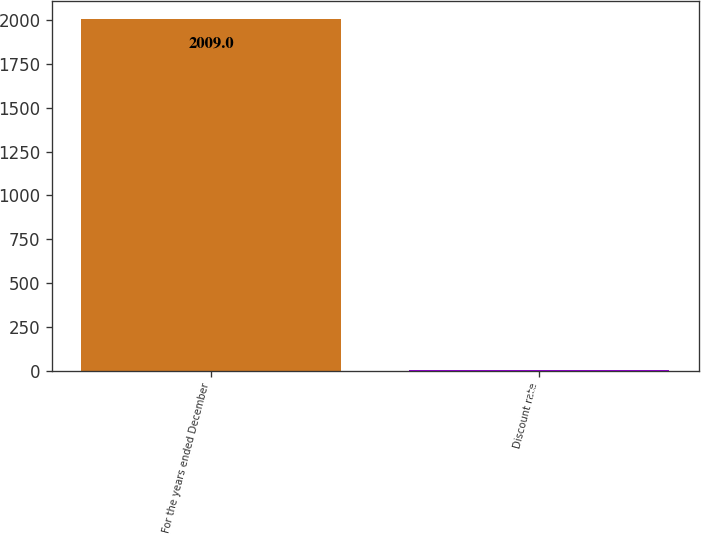<chart> <loc_0><loc_0><loc_500><loc_500><bar_chart><fcel>For the years ended December<fcel>Discount rate<nl><fcel>2009<fcel>6.4<nl></chart> 